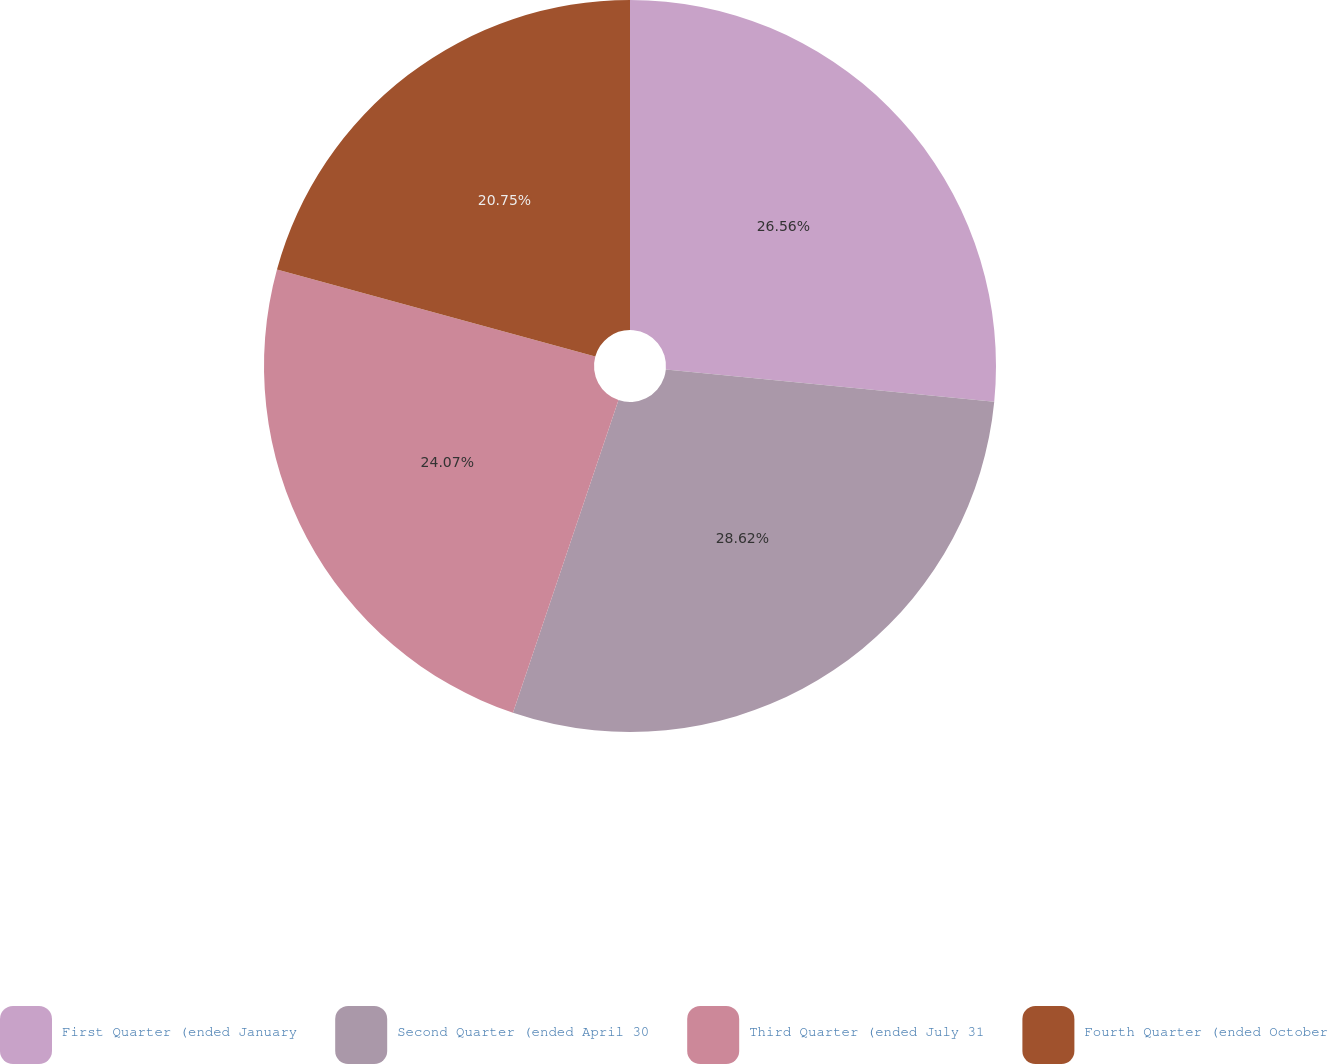<chart> <loc_0><loc_0><loc_500><loc_500><pie_chart><fcel>First Quarter (ended January<fcel>Second Quarter (ended April 30<fcel>Third Quarter (ended July 31<fcel>Fourth Quarter (ended October<nl><fcel>26.56%<fcel>28.62%<fcel>24.07%<fcel>20.75%<nl></chart> 